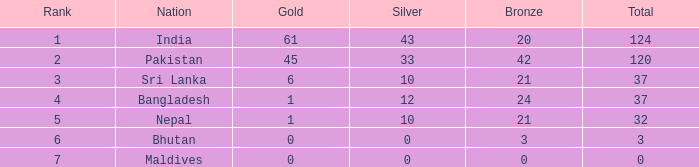Which Silver has a Rank of 6, and a Bronze smaller than 3? None. Parse the table in full. {'header': ['Rank', 'Nation', 'Gold', 'Silver', 'Bronze', 'Total'], 'rows': [['1', 'India', '61', '43', '20', '124'], ['2', 'Pakistan', '45', '33', '42', '120'], ['3', 'Sri Lanka', '6', '10', '21', '37'], ['4', 'Bangladesh', '1', '12', '24', '37'], ['5', 'Nepal', '1', '10', '21', '32'], ['6', 'Bhutan', '0', '0', '3', '3'], ['7', 'Maldives', '0', '0', '0', '0']]} 